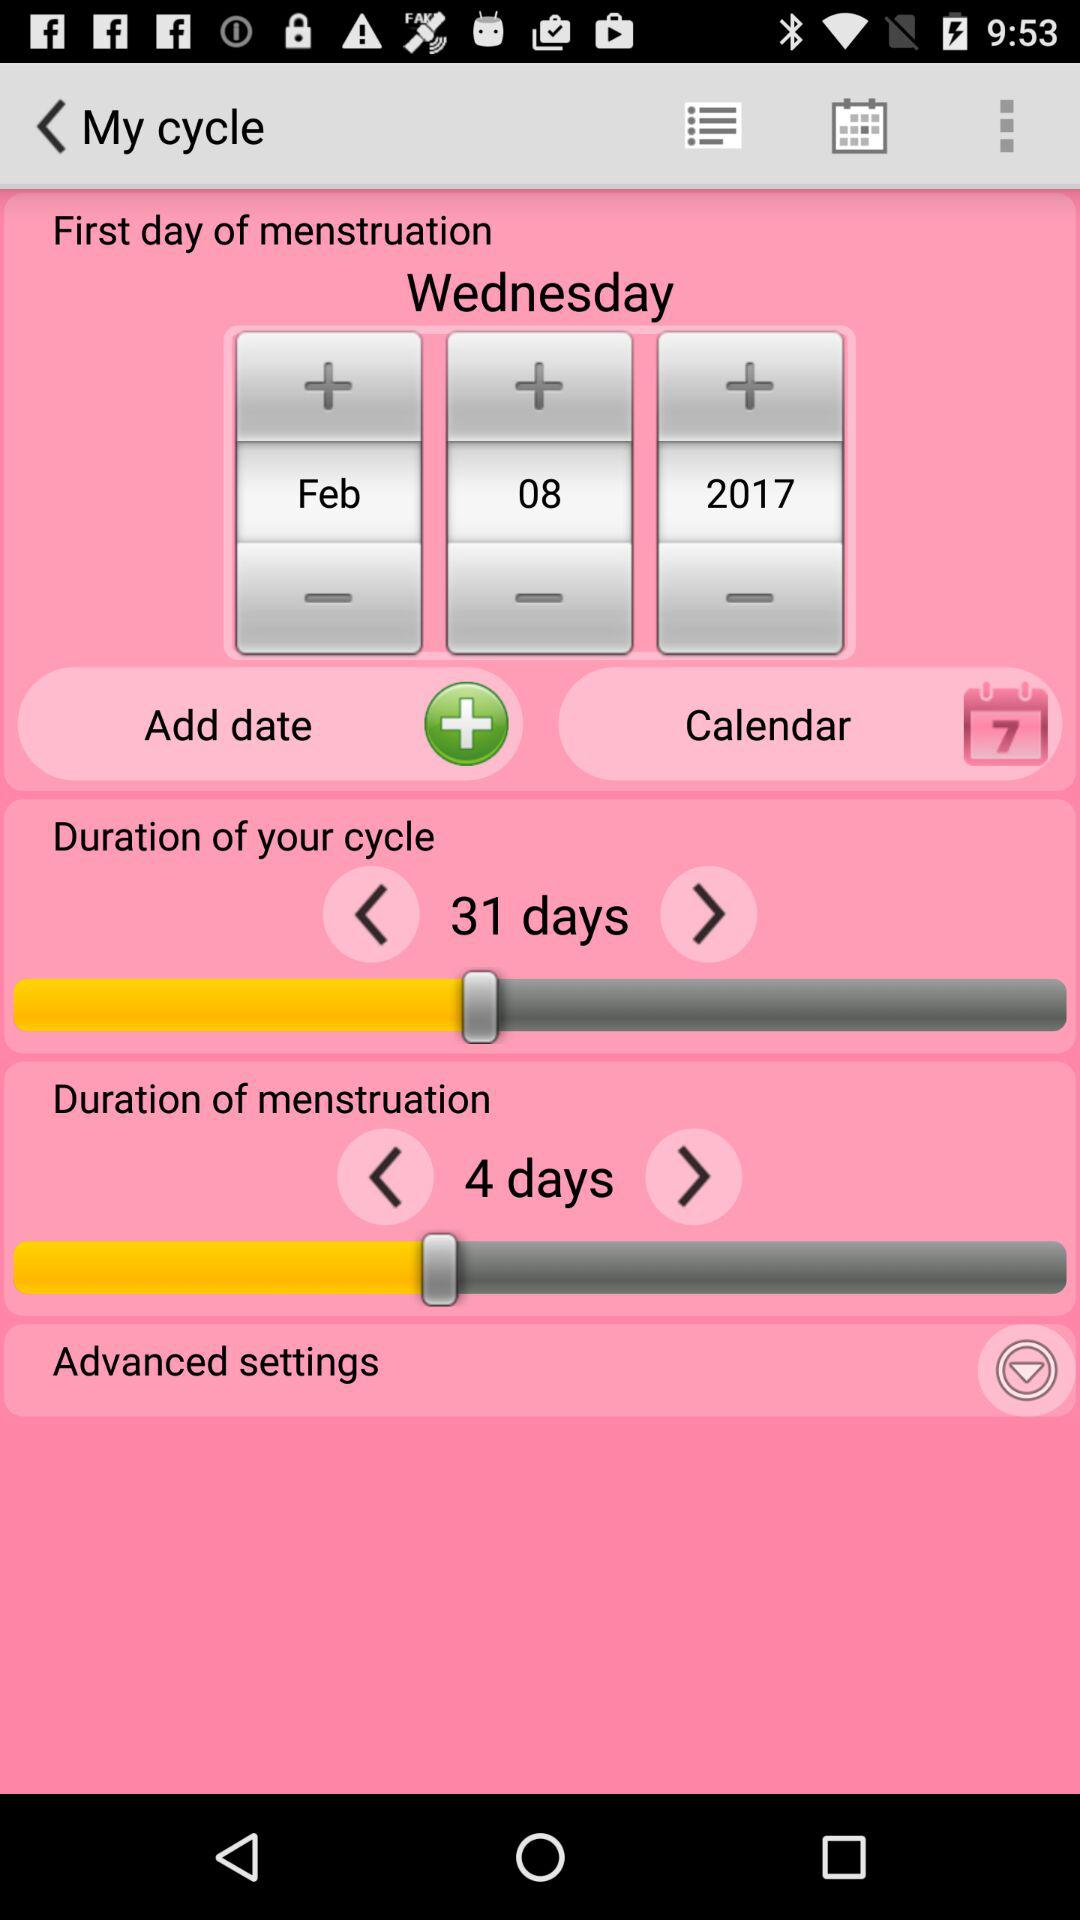What is the selected date for the first day of menstruation? The selected date is February 8, 2017. 